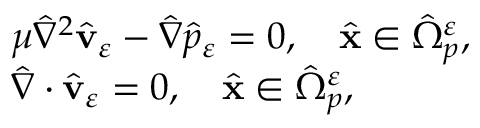<formula> <loc_0><loc_0><loc_500><loc_500>\begin{array} { r l } & { { \mu } { \hat { \nabla } } ^ { 2 } \hat { \mathbf v } _ { \varepsilon } - { \hat { \nabla } } { \hat { p } _ { \varepsilon } } = 0 , \quad \hat { \mathbf x } \in \hat { \Omega } _ { p } ^ { \varepsilon } , } \\ & { \hat { \nabla } \cdot \hat { \mathbf v } _ { \varepsilon } = 0 , \quad \hat { \mathbf x } \in \hat { \Omega } _ { p } ^ { \varepsilon } , } \end{array}</formula> 